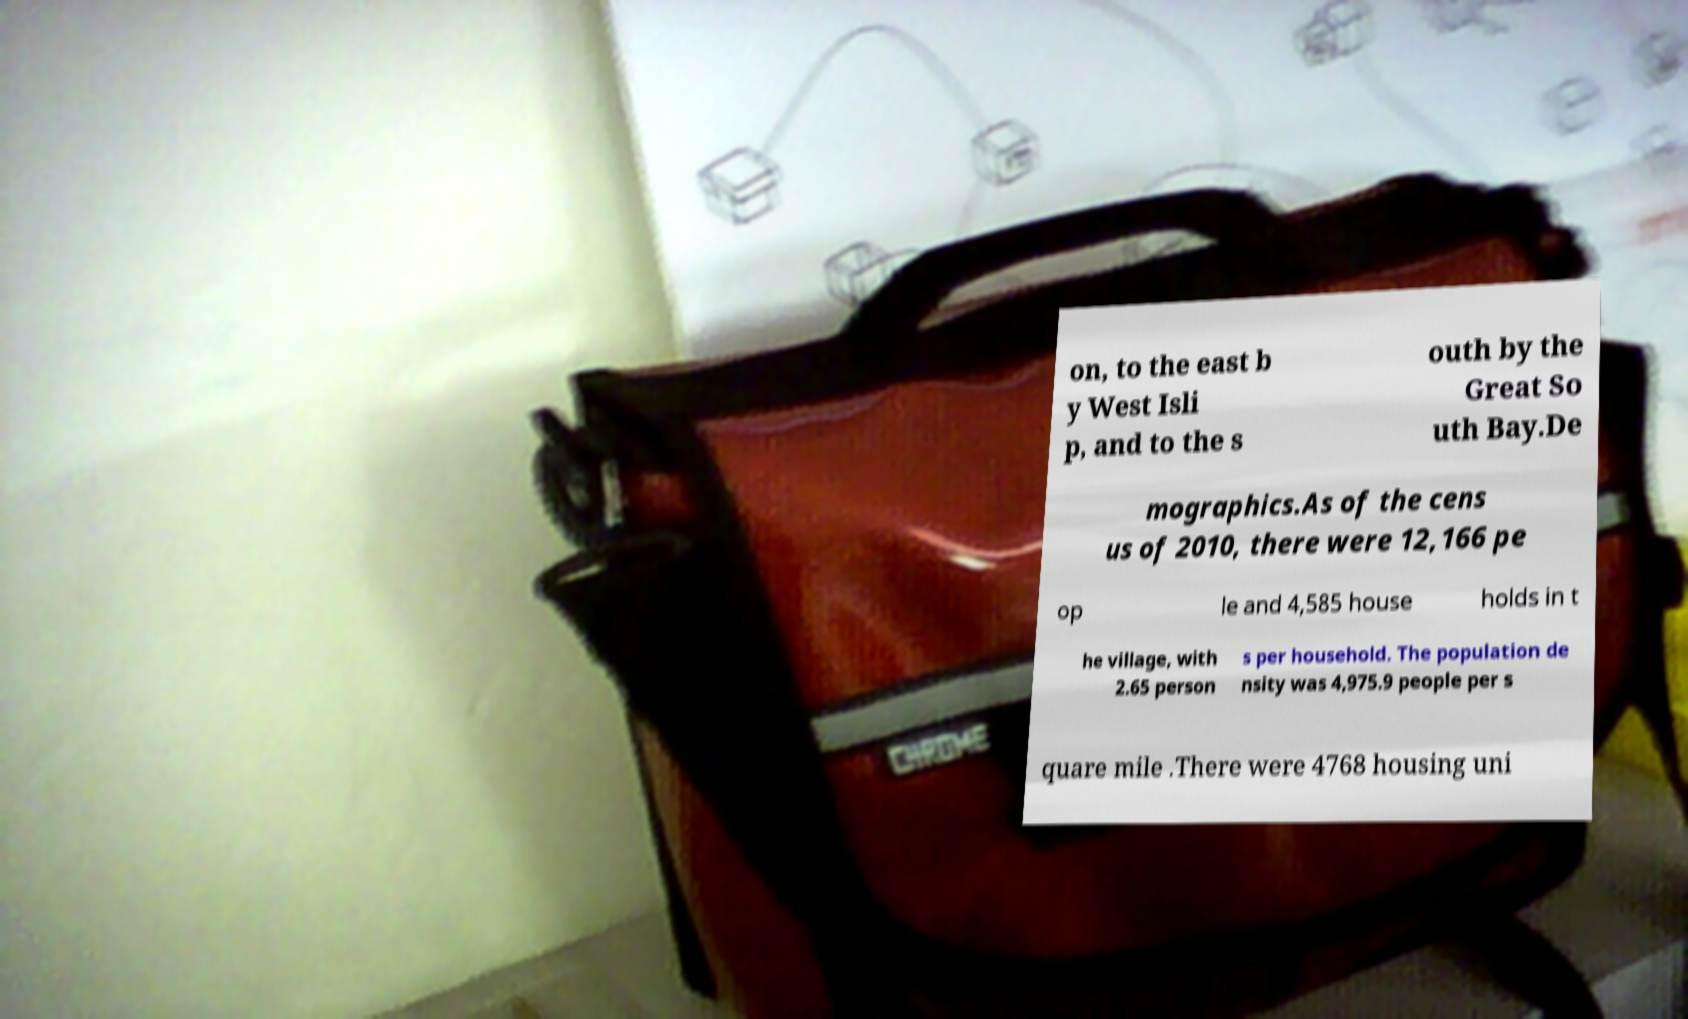I need the written content from this picture converted into text. Can you do that? on, to the east b y West Isli p, and to the s outh by the Great So uth Bay.De mographics.As of the cens us of 2010, there were 12,166 pe op le and 4,585 house holds in t he village, with 2.65 person s per household. The population de nsity was 4,975.9 people per s quare mile .There were 4768 housing uni 